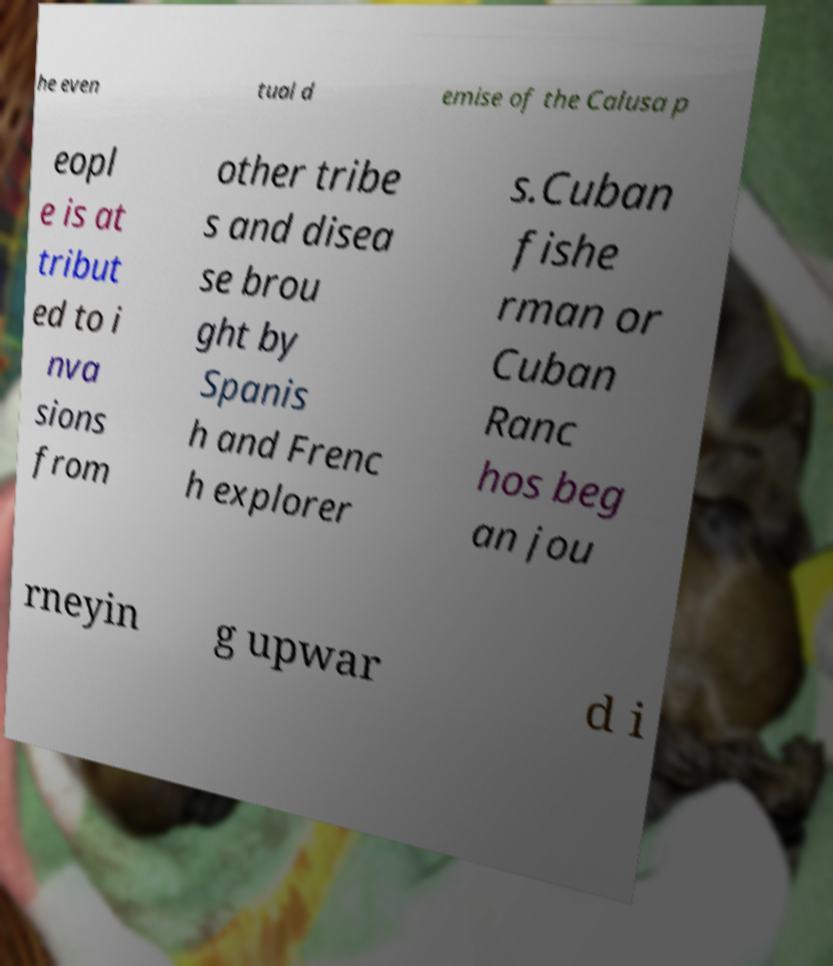Can you read and provide the text displayed in the image?This photo seems to have some interesting text. Can you extract and type it out for me? he even tual d emise of the Calusa p eopl e is at tribut ed to i nva sions from other tribe s and disea se brou ght by Spanis h and Frenc h explorer s.Cuban fishe rman or Cuban Ranc hos beg an jou rneyin g upwar d i 